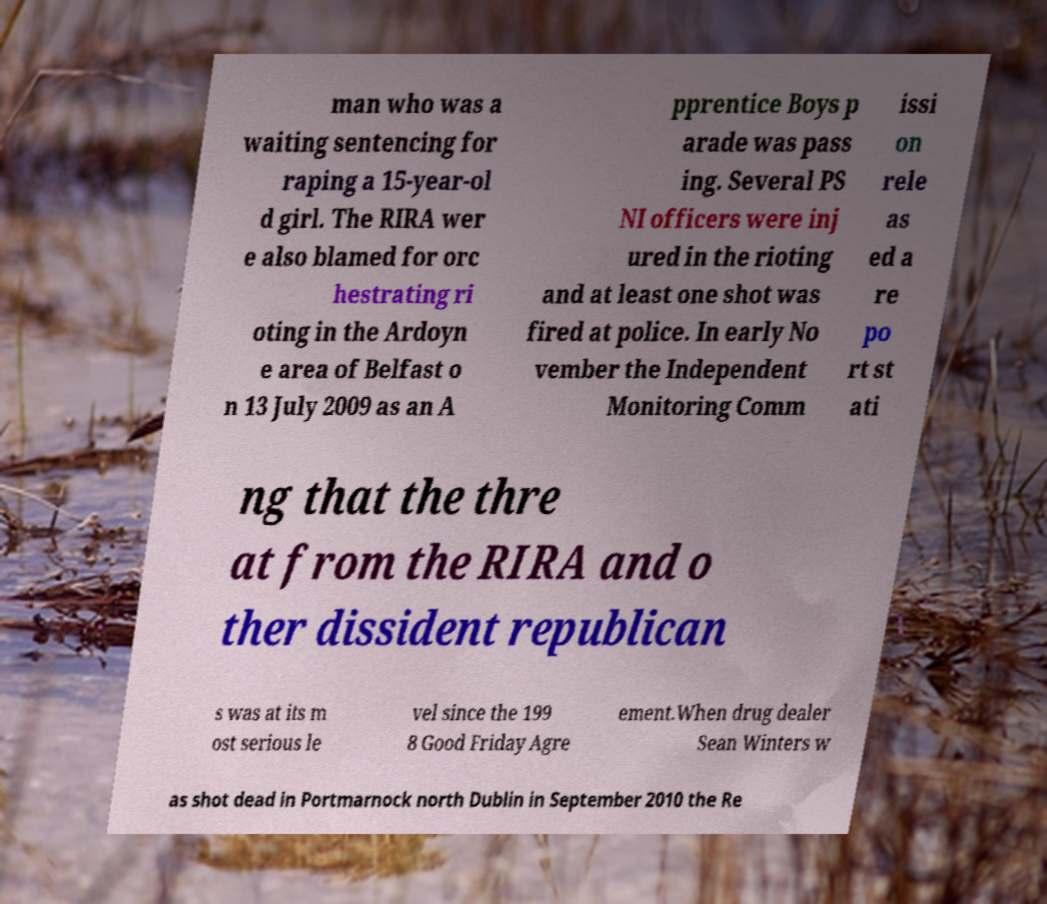What messages or text are displayed in this image? I need them in a readable, typed format. man who was a waiting sentencing for raping a 15-year-ol d girl. The RIRA wer e also blamed for orc hestrating ri oting in the Ardoyn e area of Belfast o n 13 July 2009 as an A pprentice Boys p arade was pass ing. Several PS NI officers were inj ured in the rioting and at least one shot was fired at police. In early No vember the Independent Monitoring Comm issi on rele as ed a re po rt st ati ng that the thre at from the RIRA and o ther dissident republican s was at its m ost serious le vel since the 199 8 Good Friday Agre ement.When drug dealer Sean Winters w as shot dead in Portmarnock north Dublin in September 2010 the Re 